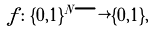Convert formula to latex. <formula><loc_0><loc_0><loc_500><loc_500>f \colon \{ 0 , 1 \} ^ { N } \longrightarrow \{ 0 , 1 \} ,</formula> 